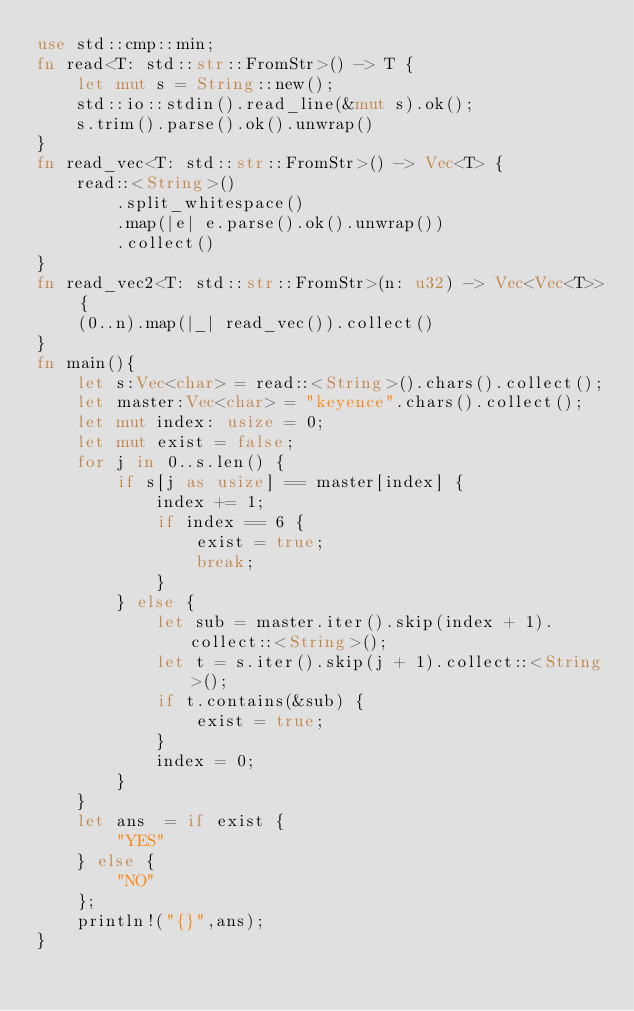Convert code to text. <code><loc_0><loc_0><loc_500><loc_500><_Rust_>use std::cmp::min;
fn read<T: std::str::FromStr>() -> T {
    let mut s = String::new();
    std::io::stdin().read_line(&mut s).ok();
    s.trim().parse().ok().unwrap()
}
fn read_vec<T: std::str::FromStr>() -> Vec<T> {
    read::<String>()
        .split_whitespace()
        .map(|e| e.parse().ok().unwrap())
        .collect()
}
fn read_vec2<T: std::str::FromStr>(n: u32) -> Vec<Vec<T>> {
    (0..n).map(|_| read_vec()).collect()
}
fn main(){
    let s:Vec<char> = read::<String>().chars().collect();
    let master:Vec<char> = "keyence".chars().collect();
    let mut index: usize = 0;
    let mut exist = false;
    for j in 0..s.len() {
        if s[j as usize] == master[index] {
            index += 1;
            if index == 6 {
                exist = true;
                break;
            }
        } else {
            let sub = master.iter().skip(index + 1).collect::<String>();
            let t = s.iter().skip(j + 1).collect::<String>();
            if t.contains(&sub) {
                exist = true;
            }
            index = 0;
        }
    }
    let ans  = if exist {
        "YES"
    } else {
        "NO"
    };
    println!("{}",ans);
}</code> 